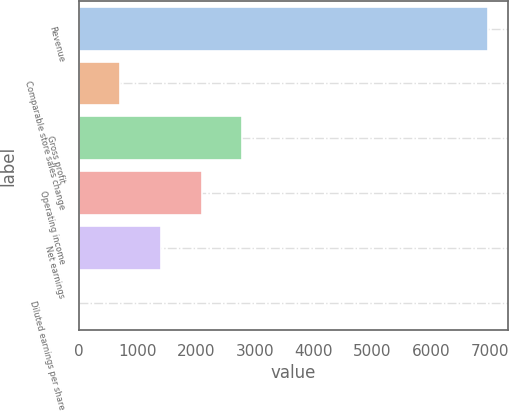Convert chart. <chart><loc_0><loc_0><loc_500><loc_500><bar_chart><fcel>Revenue<fcel>Comparable store sales change<fcel>Gross profit<fcel>Operating income<fcel>Net earnings<fcel>Diluted earnings per share<nl><fcel>6959<fcel>696.32<fcel>2783.87<fcel>2088.02<fcel>1392.17<fcel>0.47<nl></chart> 